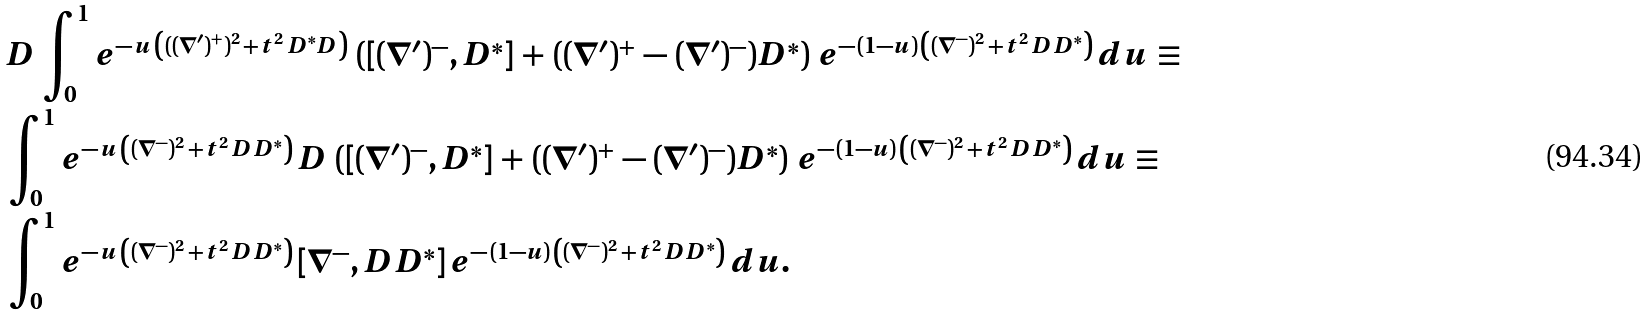Convert formula to latex. <formula><loc_0><loc_0><loc_500><loc_500>& D \, \int _ { 0 } ^ { 1 } e ^ { - \, u \, \left ( ( ( \nabla ^ { \prime } ) ^ { + } ) ^ { 2 } \, + \, t ^ { 2 } \, D ^ { * } D \right ) } \, \left ( [ ( \nabla ^ { \prime } ) ^ { - } , D ^ { * } ] \, + \, ( ( \nabla ^ { \prime } ) ^ { + } \, - \, ( \nabla ^ { \prime } ) ^ { - } ) D ^ { * } \right ) \, e ^ { - \, ( 1 - u ) \, \left ( ( \nabla ^ { - } ) ^ { 2 } \, + \, t ^ { 2 } \, D D ^ { * } \right ) } \, d u \, \equiv \, \\ & \int _ { 0 } ^ { 1 } e ^ { - \, u \, \left ( ( \nabla ^ { - } ) ^ { 2 } \, + \, t ^ { 2 } \, D D ^ { * } \right ) } \, D \, \left ( [ ( \nabla ^ { \prime } ) ^ { - } , D ^ { * } ] \, + \, ( ( \nabla ^ { \prime } ) ^ { + } \, - \, ( \nabla ^ { \prime } ) ^ { - } ) D ^ { * } \right ) \, e ^ { - \, ( 1 - u ) \, \left ( ( \nabla ^ { - } ) ^ { 2 } \, + \, t ^ { 2 } \, D D ^ { * } \right ) } \, d u \, \equiv \, \\ & \int _ { 0 } ^ { 1 } e ^ { - \, u \, \left ( ( \nabla ^ { - } ) ^ { 2 } \, + \, t ^ { 2 } \, D D ^ { * } \right ) } \, [ \nabla ^ { - } , D D ^ { * } ] \, e ^ { - \, ( 1 - u ) \, \left ( ( \nabla ^ { - } ) ^ { 2 } \, + \, t ^ { 2 } \, D D ^ { * } \right ) } \, d u .</formula> 